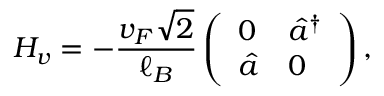<formula> <loc_0><loc_0><loc_500><loc_500>H _ { v } = - \frac { v _ { F } \sqrt { 2 } } { \ell _ { B } } \left ( \begin{array} { l l } { 0 } & { \hat { a } ^ { \dagger } } \\ { \hat { a } } & { 0 } \end{array} \right ) ,</formula> 